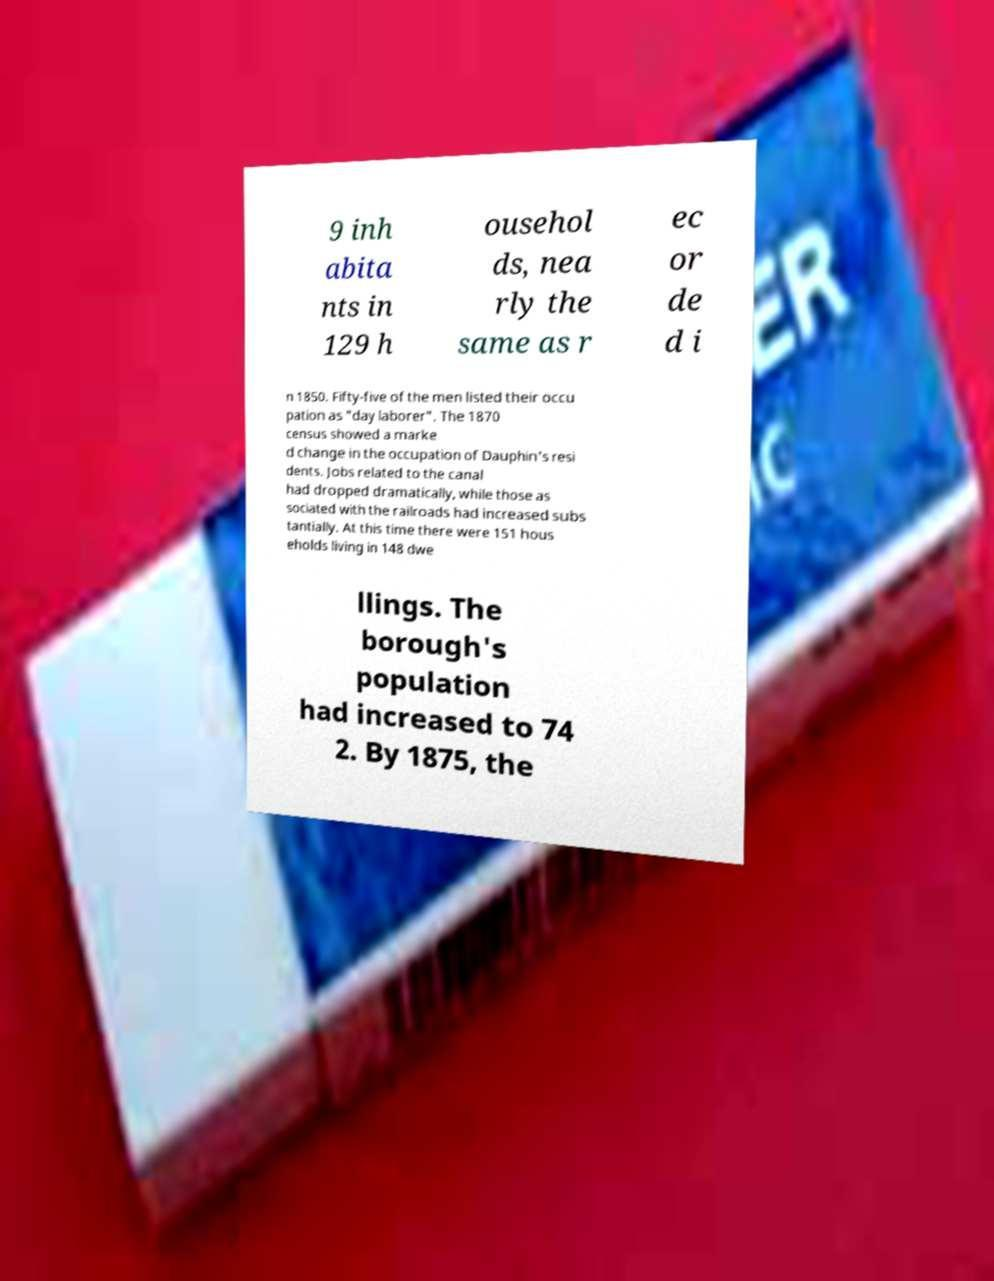What messages or text are displayed in this image? I need them in a readable, typed format. 9 inh abita nts in 129 h ousehol ds, nea rly the same as r ec or de d i n 1850. Fifty-five of the men listed their occu pation as "day laborer". The 1870 census showed a marke d change in the occupation of Dauphin's resi dents. Jobs related to the canal had dropped dramatically, while those as sociated with the railroads had increased subs tantially. At this time there were 151 hous eholds living in 148 dwe llings. The borough's population had increased to 74 2. By 1875, the 